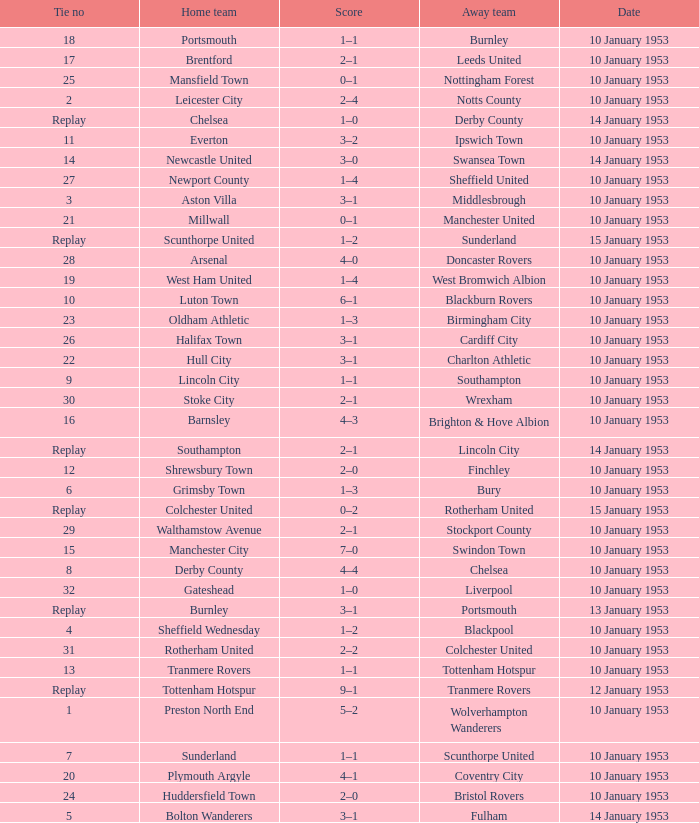What home team has coventry city as the away team? Plymouth Argyle. 